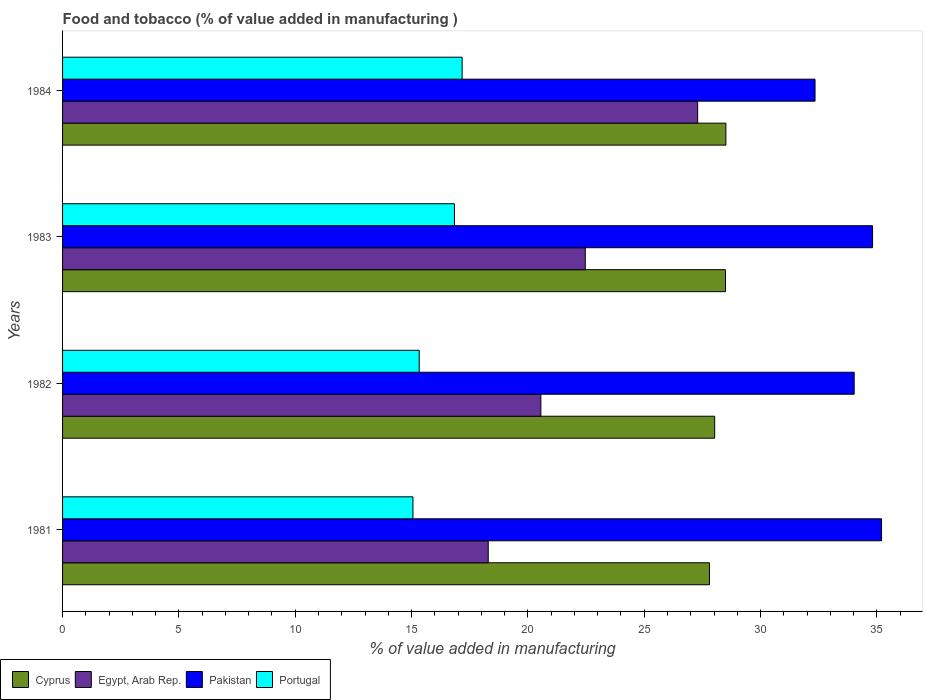How many groups of bars are there?
Make the answer very short. 4. Are the number of bars on each tick of the Y-axis equal?
Ensure brevity in your answer.  Yes. How many bars are there on the 2nd tick from the top?
Give a very brief answer. 4. How many bars are there on the 2nd tick from the bottom?
Offer a very short reply. 4. What is the label of the 2nd group of bars from the top?
Offer a very short reply. 1983. In how many cases, is the number of bars for a given year not equal to the number of legend labels?
Your answer should be very brief. 0. What is the value added in manufacturing food and tobacco in Pakistan in 1981?
Provide a short and direct response. 35.2. Across all years, what is the maximum value added in manufacturing food and tobacco in Pakistan?
Your answer should be very brief. 35.2. Across all years, what is the minimum value added in manufacturing food and tobacco in Portugal?
Your answer should be compact. 15.06. In which year was the value added in manufacturing food and tobacco in Portugal maximum?
Your answer should be compact. 1984. In which year was the value added in manufacturing food and tobacco in Cyprus minimum?
Ensure brevity in your answer.  1981. What is the total value added in manufacturing food and tobacco in Egypt, Arab Rep. in the graph?
Give a very brief answer. 88.62. What is the difference between the value added in manufacturing food and tobacco in Pakistan in 1981 and that in 1984?
Give a very brief answer. 2.86. What is the difference between the value added in manufacturing food and tobacco in Pakistan in 1983 and the value added in manufacturing food and tobacco in Cyprus in 1984?
Provide a succinct answer. 6.3. What is the average value added in manufacturing food and tobacco in Egypt, Arab Rep. per year?
Your answer should be very brief. 22.15. In the year 1982, what is the difference between the value added in manufacturing food and tobacco in Portugal and value added in manufacturing food and tobacco in Egypt, Arab Rep.?
Give a very brief answer. -5.23. What is the ratio of the value added in manufacturing food and tobacco in Cyprus in 1982 to that in 1984?
Offer a terse response. 0.98. What is the difference between the highest and the second highest value added in manufacturing food and tobacco in Cyprus?
Your answer should be compact. 0.02. What is the difference between the highest and the lowest value added in manufacturing food and tobacco in Pakistan?
Make the answer very short. 2.86. In how many years, is the value added in manufacturing food and tobacco in Cyprus greater than the average value added in manufacturing food and tobacco in Cyprus taken over all years?
Your answer should be very brief. 2. Is it the case that in every year, the sum of the value added in manufacturing food and tobacco in Portugal and value added in manufacturing food and tobacco in Pakistan is greater than the sum of value added in manufacturing food and tobacco in Cyprus and value added in manufacturing food and tobacco in Egypt, Arab Rep.?
Provide a succinct answer. Yes. What does the 2nd bar from the top in 1982 represents?
Offer a very short reply. Pakistan. What does the 2nd bar from the bottom in 1981 represents?
Provide a short and direct response. Egypt, Arab Rep. Is it the case that in every year, the sum of the value added in manufacturing food and tobacco in Portugal and value added in manufacturing food and tobacco in Cyprus is greater than the value added in manufacturing food and tobacco in Pakistan?
Keep it short and to the point. Yes. Does the graph contain any zero values?
Offer a terse response. No. Does the graph contain grids?
Provide a succinct answer. No. Where does the legend appear in the graph?
Offer a terse response. Bottom left. How are the legend labels stacked?
Provide a short and direct response. Horizontal. What is the title of the graph?
Your answer should be very brief. Food and tobacco (% of value added in manufacturing ). What is the label or title of the X-axis?
Provide a short and direct response. % of value added in manufacturing. What is the label or title of the Y-axis?
Ensure brevity in your answer.  Years. What is the % of value added in manufacturing of Cyprus in 1981?
Provide a succinct answer. 27.81. What is the % of value added in manufacturing of Egypt, Arab Rep. in 1981?
Ensure brevity in your answer.  18.3. What is the % of value added in manufacturing in Pakistan in 1981?
Your response must be concise. 35.2. What is the % of value added in manufacturing in Portugal in 1981?
Your response must be concise. 15.06. What is the % of value added in manufacturing of Cyprus in 1982?
Ensure brevity in your answer.  28.03. What is the % of value added in manufacturing in Egypt, Arab Rep. in 1982?
Keep it short and to the point. 20.56. What is the % of value added in manufacturing in Pakistan in 1982?
Offer a terse response. 34.03. What is the % of value added in manufacturing of Portugal in 1982?
Your answer should be compact. 15.33. What is the % of value added in manufacturing in Cyprus in 1983?
Provide a succinct answer. 28.49. What is the % of value added in manufacturing in Egypt, Arab Rep. in 1983?
Make the answer very short. 22.47. What is the % of value added in manufacturing in Pakistan in 1983?
Provide a succinct answer. 34.82. What is the % of value added in manufacturing of Portugal in 1983?
Your answer should be compact. 16.84. What is the % of value added in manufacturing in Cyprus in 1984?
Provide a short and direct response. 28.51. What is the % of value added in manufacturing in Egypt, Arab Rep. in 1984?
Provide a short and direct response. 27.3. What is the % of value added in manufacturing in Pakistan in 1984?
Offer a terse response. 32.34. What is the % of value added in manufacturing of Portugal in 1984?
Your response must be concise. 17.17. Across all years, what is the maximum % of value added in manufacturing in Cyprus?
Your answer should be compact. 28.51. Across all years, what is the maximum % of value added in manufacturing in Egypt, Arab Rep.?
Provide a succinct answer. 27.3. Across all years, what is the maximum % of value added in manufacturing of Pakistan?
Your answer should be very brief. 35.2. Across all years, what is the maximum % of value added in manufacturing of Portugal?
Give a very brief answer. 17.17. Across all years, what is the minimum % of value added in manufacturing of Cyprus?
Make the answer very short. 27.81. Across all years, what is the minimum % of value added in manufacturing of Egypt, Arab Rep.?
Give a very brief answer. 18.3. Across all years, what is the minimum % of value added in manufacturing of Pakistan?
Provide a short and direct response. 32.34. Across all years, what is the minimum % of value added in manufacturing of Portugal?
Offer a terse response. 15.06. What is the total % of value added in manufacturing in Cyprus in the graph?
Keep it short and to the point. 112.84. What is the total % of value added in manufacturing of Egypt, Arab Rep. in the graph?
Your response must be concise. 88.62. What is the total % of value added in manufacturing in Pakistan in the graph?
Your answer should be compact. 136.38. What is the total % of value added in manufacturing in Portugal in the graph?
Your answer should be compact. 64.41. What is the difference between the % of value added in manufacturing in Cyprus in 1981 and that in 1982?
Offer a terse response. -0.22. What is the difference between the % of value added in manufacturing of Egypt, Arab Rep. in 1981 and that in 1982?
Make the answer very short. -2.26. What is the difference between the % of value added in manufacturing of Pakistan in 1981 and that in 1982?
Make the answer very short. 1.18. What is the difference between the % of value added in manufacturing of Portugal in 1981 and that in 1982?
Your answer should be compact. -0.27. What is the difference between the % of value added in manufacturing of Cyprus in 1981 and that in 1983?
Ensure brevity in your answer.  -0.69. What is the difference between the % of value added in manufacturing of Egypt, Arab Rep. in 1981 and that in 1983?
Your answer should be compact. -4.17. What is the difference between the % of value added in manufacturing in Pakistan in 1981 and that in 1983?
Keep it short and to the point. 0.39. What is the difference between the % of value added in manufacturing of Portugal in 1981 and that in 1983?
Ensure brevity in your answer.  -1.78. What is the difference between the % of value added in manufacturing in Cyprus in 1981 and that in 1984?
Give a very brief answer. -0.71. What is the difference between the % of value added in manufacturing in Egypt, Arab Rep. in 1981 and that in 1984?
Make the answer very short. -9. What is the difference between the % of value added in manufacturing of Pakistan in 1981 and that in 1984?
Keep it short and to the point. 2.86. What is the difference between the % of value added in manufacturing in Portugal in 1981 and that in 1984?
Ensure brevity in your answer.  -2.11. What is the difference between the % of value added in manufacturing of Cyprus in 1982 and that in 1983?
Offer a terse response. -0.47. What is the difference between the % of value added in manufacturing in Egypt, Arab Rep. in 1982 and that in 1983?
Ensure brevity in your answer.  -1.91. What is the difference between the % of value added in manufacturing in Pakistan in 1982 and that in 1983?
Provide a short and direct response. -0.79. What is the difference between the % of value added in manufacturing in Portugal in 1982 and that in 1983?
Provide a short and direct response. -1.51. What is the difference between the % of value added in manufacturing in Cyprus in 1982 and that in 1984?
Provide a succinct answer. -0.48. What is the difference between the % of value added in manufacturing of Egypt, Arab Rep. in 1982 and that in 1984?
Give a very brief answer. -6.74. What is the difference between the % of value added in manufacturing of Pakistan in 1982 and that in 1984?
Offer a very short reply. 1.68. What is the difference between the % of value added in manufacturing of Portugal in 1982 and that in 1984?
Keep it short and to the point. -1.84. What is the difference between the % of value added in manufacturing of Cyprus in 1983 and that in 1984?
Give a very brief answer. -0.02. What is the difference between the % of value added in manufacturing of Egypt, Arab Rep. in 1983 and that in 1984?
Provide a succinct answer. -4.83. What is the difference between the % of value added in manufacturing in Pakistan in 1983 and that in 1984?
Keep it short and to the point. 2.47. What is the difference between the % of value added in manufacturing of Portugal in 1983 and that in 1984?
Your answer should be very brief. -0.33. What is the difference between the % of value added in manufacturing of Cyprus in 1981 and the % of value added in manufacturing of Egypt, Arab Rep. in 1982?
Provide a short and direct response. 7.25. What is the difference between the % of value added in manufacturing of Cyprus in 1981 and the % of value added in manufacturing of Pakistan in 1982?
Your answer should be very brief. -6.22. What is the difference between the % of value added in manufacturing of Cyprus in 1981 and the % of value added in manufacturing of Portugal in 1982?
Your answer should be compact. 12.48. What is the difference between the % of value added in manufacturing in Egypt, Arab Rep. in 1981 and the % of value added in manufacturing in Pakistan in 1982?
Your answer should be compact. -15.73. What is the difference between the % of value added in manufacturing of Egypt, Arab Rep. in 1981 and the % of value added in manufacturing of Portugal in 1982?
Provide a succinct answer. 2.97. What is the difference between the % of value added in manufacturing of Pakistan in 1981 and the % of value added in manufacturing of Portugal in 1982?
Ensure brevity in your answer.  19.87. What is the difference between the % of value added in manufacturing of Cyprus in 1981 and the % of value added in manufacturing of Egypt, Arab Rep. in 1983?
Your answer should be very brief. 5.34. What is the difference between the % of value added in manufacturing of Cyprus in 1981 and the % of value added in manufacturing of Pakistan in 1983?
Provide a short and direct response. -7.01. What is the difference between the % of value added in manufacturing of Cyprus in 1981 and the % of value added in manufacturing of Portugal in 1983?
Make the answer very short. 10.96. What is the difference between the % of value added in manufacturing of Egypt, Arab Rep. in 1981 and the % of value added in manufacturing of Pakistan in 1983?
Your response must be concise. -16.52. What is the difference between the % of value added in manufacturing of Egypt, Arab Rep. in 1981 and the % of value added in manufacturing of Portugal in 1983?
Make the answer very short. 1.45. What is the difference between the % of value added in manufacturing of Pakistan in 1981 and the % of value added in manufacturing of Portugal in 1983?
Offer a terse response. 18.36. What is the difference between the % of value added in manufacturing in Cyprus in 1981 and the % of value added in manufacturing in Egypt, Arab Rep. in 1984?
Offer a terse response. 0.51. What is the difference between the % of value added in manufacturing in Cyprus in 1981 and the % of value added in manufacturing in Pakistan in 1984?
Give a very brief answer. -4.54. What is the difference between the % of value added in manufacturing in Cyprus in 1981 and the % of value added in manufacturing in Portugal in 1984?
Offer a very short reply. 10.63. What is the difference between the % of value added in manufacturing in Egypt, Arab Rep. in 1981 and the % of value added in manufacturing in Pakistan in 1984?
Offer a terse response. -14.05. What is the difference between the % of value added in manufacturing in Egypt, Arab Rep. in 1981 and the % of value added in manufacturing in Portugal in 1984?
Ensure brevity in your answer.  1.12. What is the difference between the % of value added in manufacturing of Pakistan in 1981 and the % of value added in manufacturing of Portugal in 1984?
Provide a short and direct response. 18.03. What is the difference between the % of value added in manufacturing of Cyprus in 1982 and the % of value added in manufacturing of Egypt, Arab Rep. in 1983?
Your answer should be compact. 5.56. What is the difference between the % of value added in manufacturing of Cyprus in 1982 and the % of value added in manufacturing of Pakistan in 1983?
Offer a very short reply. -6.79. What is the difference between the % of value added in manufacturing in Cyprus in 1982 and the % of value added in manufacturing in Portugal in 1983?
Keep it short and to the point. 11.18. What is the difference between the % of value added in manufacturing in Egypt, Arab Rep. in 1982 and the % of value added in manufacturing in Pakistan in 1983?
Your answer should be very brief. -14.26. What is the difference between the % of value added in manufacturing in Egypt, Arab Rep. in 1982 and the % of value added in manufacturing in Portugal in 1983?
Your answer should be compact. 3.71. What is the difference between the % of value added in manufacturing in Pakistan in 1982 and the % of value added in manufacturing in Portugal in 1983?
Provide a short and direct response. 17.18. What is the difference between the % of value added in manufacturing of Cyprus in 1982 and the % of value added in manufacturing of Egypt, Arab Rep. in 1984?
Your answer should be very brief. 0.73. What is the difference between the % of value added in manufacturing in Cyprus in 1982 and the % of value added in manufacturing in Pakistan in 1984?
Your answer should be very brief. -4.31. What is the difference between the % of value added in manufacturing of Cyprus in 1982 and the % of value added in manufacturing of Portugal in 1984?
Provide a succinct answer. 10.85. What is the difference between the % of value added in manufacturing in Egypt, Arab Rep. in 1982 and the % of value added in manufacturing in Pakistan in 1984?
Your answer should be very brief. -11.78. What is the difference between the % of value added in manufacturing of Egypt, Arab Rep. in 1982 and the % of value added in manufacturing of Portugal in 1984?
Your answer should be compact. 3.38. What is the difference between the % of value added in manufacturing in Pakistan in 1982 and the % of value added in manufacturing in Portugal in 1984?
Your answer should be compact. 16.85. What is the difference between the % of value added in manufacturing of Cyprus in 1983 and the % of value added in manufacturing of Egypt, Arab Rep. in 1984?
Make the answer very short. 1.2. What is the difference between the % of value added in manufacturing of Cyprus in 1983 and the % of value added in manufacturing of Pakistan in 1984?
Your response must be concise. -3.85. What is the difference between the % of value added in manufacturing of Cyprus in 1983 and the % of value added in manufacturing of Portugal in 1984?
Keep it short and to the point. 11.32. What is the difference between the % of value added in manufacturing in Egypt, Arab Rep. in 1983 and the % of value added in manufacturing in Pakistan in 1984?
Make the answer very short. -9.88. What is the difference between the % of value added in manufacturing in Egypt, Arab Rep. in 1983 and the % of value added in manufacturing in Portugal in 1984?
Your answer should be compact. 5.29. What is the difference between the % of value added in manufacturing in Pakistan in 1983 and the % of value added in manufacturing in Portugal in 1984?
Give a very brief answer. 17.64. What is the average % of value added in manufacturing in Cyprus per year?
Ensure brevity in your answer.  28.21. What is the average % of value added in manufacturing in Egypt, Arab Rep. per year?
Offer a very short reply. 22.15. What is the average % of value added in manufacturing of Pakistan per year?
Give a very brief answer. 34.1. What is the average % of value added in manufacturing in Portugal per year?
Your response must be concise. 16.1. In the year 1981, what is the difference between the % of value added in manufacturing in Cyprus and % of value added in manufacturing in Egypt, Arab Rep.?
Make the answer very short. 9.51. In the year 1981, what is the difference between the % of value added in manufacturing in Cyprus and % of value added in manufacturing in Pakistan?
Your response must be concise. -7.4. In the year 1981, what is the difference between the % of value added in manufacturing in Cyprus and % of value added in manufacturing in Portugal?
Offer a terse response. 12.74. In the year 1981, what is the difference between the % of value added in manufacturing in Egypt, Arab Rep. and % of value added in manufacturing in Pakistan?
Provide a succinct answer. -16.91. In the year 1981, what is the difference between the % of value added in manufacturing in Egypt, Arab Rep. and % of value added in manufacturing in Portugal?
Your answer should be very brief. 3.24. In the year 1981, what is the difference between the % of value added in manufacturing in Pakistan and % of value added in manufacturing in Portugal?
Offer a terse response. 20.14. In the year 1982, what is the difference between the % of value added in manufacturing in Cyprus and % of value added in manufacturing in Egypt, Arab Rep.?
Ensure brevity in your answer.  7.47. In the year 1982, what is the difference between the % of value added in manufacturing of Cyprus and % of value added in manufacturing of Pakistan?
Give a very brief answer. -6. In the year 1982, what is the difference between the % of value added in manufacturing of Cyprus and % of value added in manufacturing of Portugal?
Keep it short and to the point. 12.7. In the year 1982, what is the difference between the % of value added in manufacturing of Egypt, Arab Rep. and % of value added in manufacturing of Pakistan?
Keep it short and to the point. -13.47. In the year 1982, what is the difference between the % of value added in manufacturing of Egypt, Arab Rep. and % of value added in manufacturing of Portugal?
Ensure brevity in your answer.  5.23. In the year 1982, what is the difference between the % of value added in manufacturing of Pakistan and % of value added in manufacturing of Portugal?
Provide a succinct answer. 18.7. In the year 1983, what is the difference between the % of value added in manufacturing in Cyprus and % of value added in manufacturing in Egypt, Arab Rep.?
Your answer should be compact. 6.03. In the year 1983, what is the difference between the % of value added in manufacturing of Cyprus and % of value added in manufacturing of Pakistan?
Offer a terse response. -6.32. In the year 1983, what is the difference between the % of value added in manufacturing of Cyprus and % of value added in manufacturing of Portugal?
Your response must be concise. 11.65. In the year 1983, what is the difference between the % of value added in manufacturing in Egypt, Arab Rep. and % of value added in manufacturing in Pakistan?
Provide a succinct answer. -12.35. In the year 1983, what is the difference between the % of value added in manufacturing of Egypt, Arab Rep. and % of value added in manufacturing of Portugal?
Offer a terse response. 5.62. In the year 1983, what is the difference between the % of value added in manufacturing of Pakistan and % of value added in manufacturing of Portugal?
Ensure brevity in your answer.  17.97. In the year 1984, what is the difference between the % of value added in manufacturing of Cyprus and % of value added in manufacturing of Egypt, Arab Rep.?
Offer a terse response. 1.21. In the year 1984, what is the difference between the % of value added in manufacturing of Cyprus and % of value added in manufacturing of Pakistan?
Ensure brevity in your answer.  -3.83. In the year 1984, what is the difference between the % of value added in manufacturing in Cyprus and % of value added in manufacturing in Portugal?
Offer a very short reply. 11.34. In the year 1984, what is the difference between the % of value added in manufacturing of Egypt, Arab Rep. and % of value added in manufacturing of Pakistan?
Provide a short and direct response. -5.05. In the year 1984, what is the difference between the % of value added in manufacturing in Egypt, Arab Rep. and % of value added in manufacturing in Portugal?
Give a very brief answer. 10.12. In the year 1984, what is the difference between the % of value added in manufacturing of Pakistan and % of value added in manufacturing of Portugal?
Your answer should be compact. 15.17. What is the ratio of the % of value added in manufacturing in Egypt, Arab Rep. in 1981 to that in 1982?
Provide a succinct answer. 0.89. What is the ratio of the % of value added in manufacturing of Pakistan in 1981 to that in 1982?
Ensure brevity in your answer.  1.03. What is the ratio of the % of value added in manufacturing in Portugal in 1981 to that in 1982?
Make the answer very short. 0.98. What is the ratio of the % of value added in manufacturing of Cyprus in 1981 to that in 1983?
Your response must be concise. 0.98. What is the ratio of the % of value added in manufacturing of Egypt, Arab Rep. in 1981 to that in 1983?
Provide a succinct answer. 0.81. What is the ratio of the % of value added in manufacturing in Pakistan in 1981 to that in 1983?
Offer a terse response. 1.01. What is the ratio of the % of value added in manufacturing in Portugal in 1981 to that in 1983?
Your answer should be very brief. 0.89. What is the ratio of the % of value added in manufacturing of Cyprus in 1981 to that in 1984?
Give a very brief answer. 0.98. What is the ratio of the % of value added in manufacturing in Egypt, Arab Rep. in 1981 to that in 1984?
Provide a succinct answer. 0.67. What is the ratio of the % of value added in manufacturing of Pakistan in 1981 to that in 1984?
Your response must be concise. 1.09. What is the ratio of the % of value added in manufacturing of Portugal in 1981 to that in 1984?
Keep it short and to the point. 0.88. What is the ratio of the % of value added in manufacturing in Cyprus in 1982 to that in 1983?
Make the answer very short. 0.98. What is the ratio of the % of value added in manufacturing of Egypt, Arab Rep. in 1982 to that in 1983?
Offer a terse response. 0.92. What is the ratio of the % of value added in manufacturing of Pakistan in 1982 to that in 1983?
Provide a short and direct response. 0.98. What is the ratio of the % of value added in manufacturing in Portugal in 1982 to that in 1983?
Provide a succinct answer. 0.91. What is the ratio of the % of value added in manufacturing of Cyprus in 1982 to that in 1984?
Your response must be concise. 0.98. What is the ratio of the % of value added in manufacturing of Egypt, Arab Rep. in 1982 to that in 1984?
Your answer should be very brief. 0.75. What is the ratio of the % of value added in manufacturing of Pakistan in 1982 to that in 1984?
Ensure brevity in your answer.  1.05. What is the ratio of the % of value added in manufacturing of Portugal in 1982 to that in 1984?
Offer a terse response. 0.89. What is the ratio of the % of value added in manufacturing in Egypt, Arab Rep. in 1983 to that in 1984?
Offer a very short reply. 0.82. What is the ratio of the % of value added in manufacturing of Pakistan in 1983 to that in 1984?
Ensure brevity in your answer.  1.08. What is the ratio of the % of value added in manufacturing of Portugal in 1983 to that in 1984?
Your answer should be compact. 0.98. What is the difference between the highest and the second highest % of value added in manufacturing of Cyprus?
Your answer should be compact. 0.02. What is the difference between the highest and the second highest % of value added in manufacturing of Egypt, Arab Rep.?
Make the answer very short. 4.83. What is the difference between the highest and the second highest % of value added in manufacturing in Pakistan?
Your answer should be compact. 0.39. What is the difference between the highest and the second highest % of value added in manufacturing of Portugal?
Keep it short and to the point. 0.33. What is the difference between the highest and the lowest % of value added in manufacturing of Cyprus?
Provide a succinct answer. 0.71. What is the difference between the highest and the lowest % of value added in manufacturing of Egypt, Arab Rep.?
Offer a very short reply. 9. What is the difference between the highest and the lowest % of value added in manufacturing of Pakistan?
Give a very brief answer. 2.86. What is the difference between the highest and the lowest % of value added in manufacturing of Portugal?
Give a very brief answer. 2.11. 